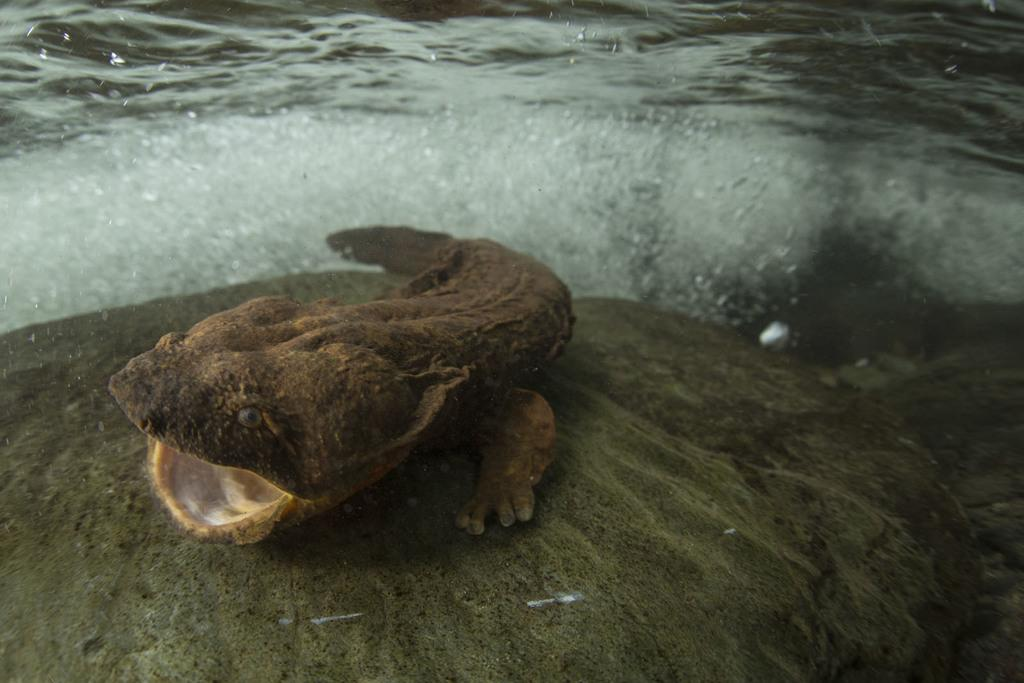What type of animal is in the image? There is a mammal in the image. Where is the mammal located? The mammal is on a rock surface. What else can be seen in the image besides the mammal? There is water visible in the image. What type of scarecrow can be seen in the image? There is no scarecrow present in the image; it features a mammal on a rock surface and water. What downtown area is visible in the image? There is no downtown area present in the image; it features a mammal on a rock surface and water. 